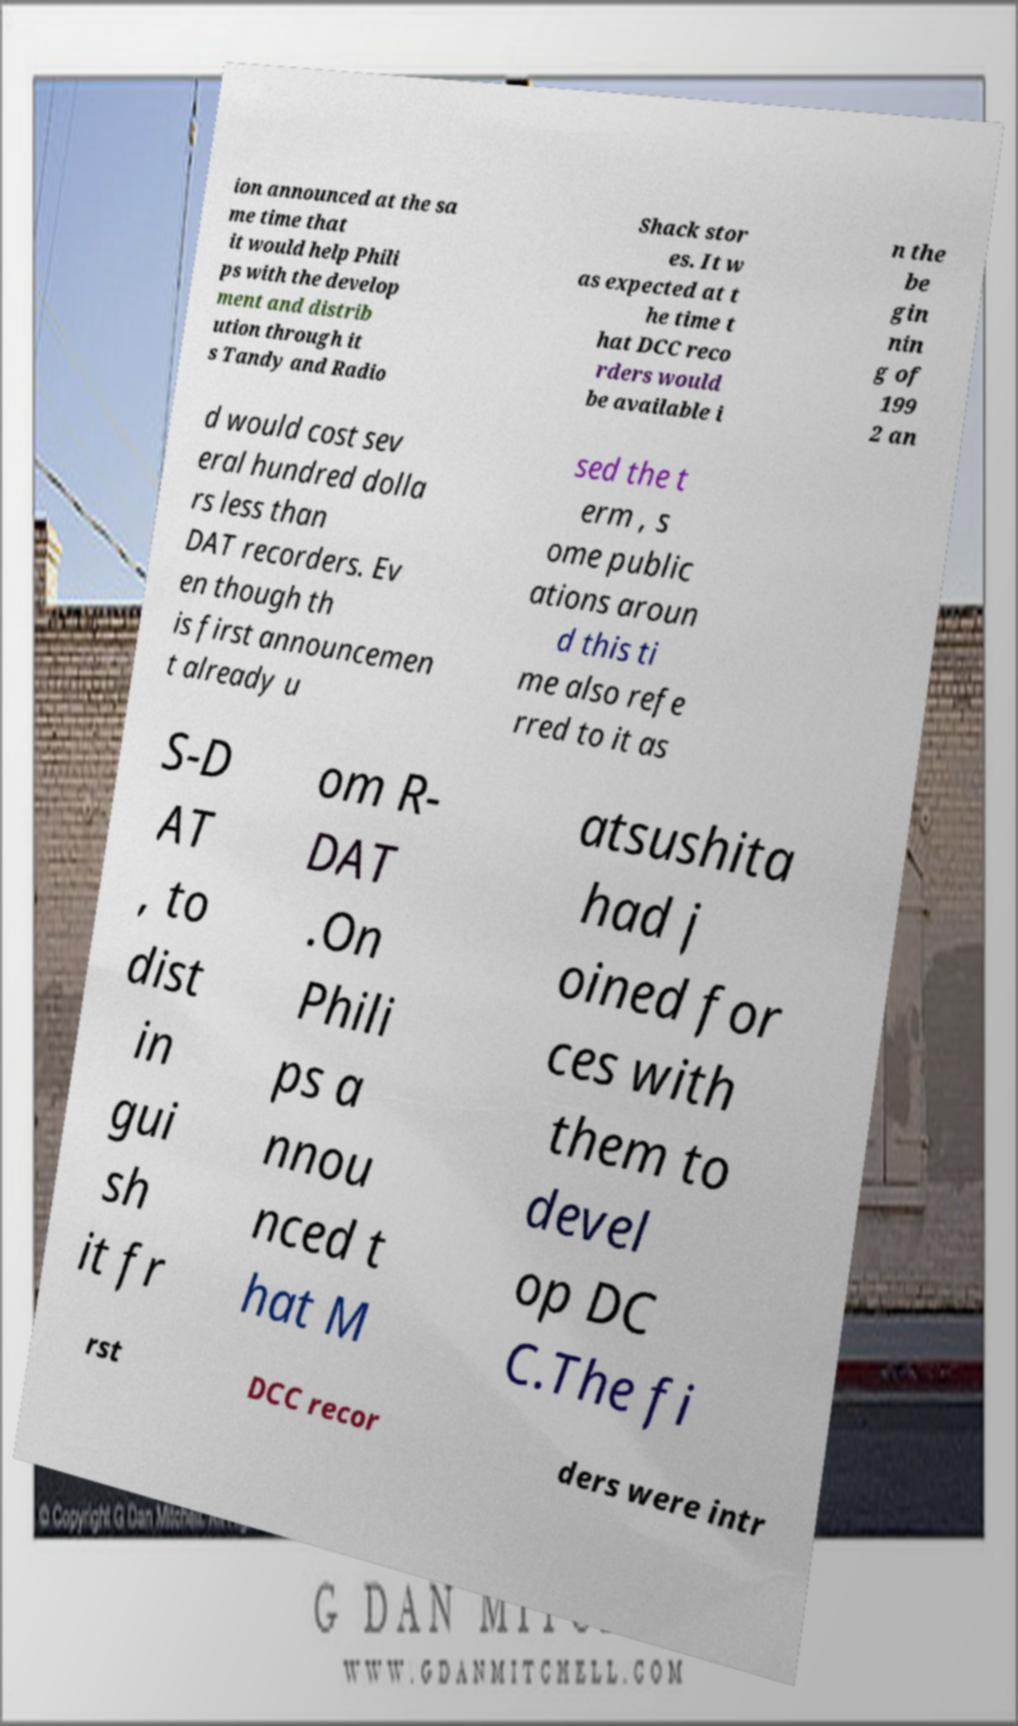What messages or text are displayed in this image? I need them in a readable, typed format. ion announced at the sa me time that it would help Phili ps with the develop ment and distrib ution through it s Tandy and Radio Shack stor es. It w as expected at t he time t hat DCC reco rders would be available i n the be gin nin g of 199 2 an d would cost sev eral hundred dolla rs less than DAT recorders. Ev en though th is first announcemen t already u sed the t erm , s ome public ations aroun d this ti me also refe rred to it as S-D AT , to dist in gui sh it fr om R- DAT .On Phili ps a nnou nced t hat M atsushita had j oined for ces with them to devel op DC C.The fi rst DCC recor ders were intr 